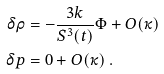Convert formula to latex. <formula><loc_0><loc_0><loc_500><loc_500>\delta \rho & = - \frac { 3 k } { S ^ { 3 } ( t ) } \Phi + O ( \kappa ) \\ \delta p & = 0 + O ( \kappa ) \ .</formula> 